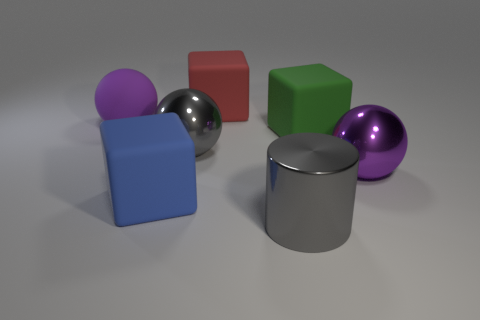Subtract all big gray metallic spheres. How many spheres are left? 2 Subtract all red cylinders. How many purple spheres are left? 2 Subtract 1 balls. How many balls are left? 2 Add 2 brown metallic objects. How many objects exist? 9 Subtract all blocks. How many objects are left? 4 Subtract 0 brown balls. How many objects are left? 7 Subtract all tiny green spheres. Subtract all green objects. How many objects are left? 6 Add 2 purple matte objects. How many purple matte objects are left? 3 Add 1 green rubber blocks. How many green rubber blocks exist? 2 